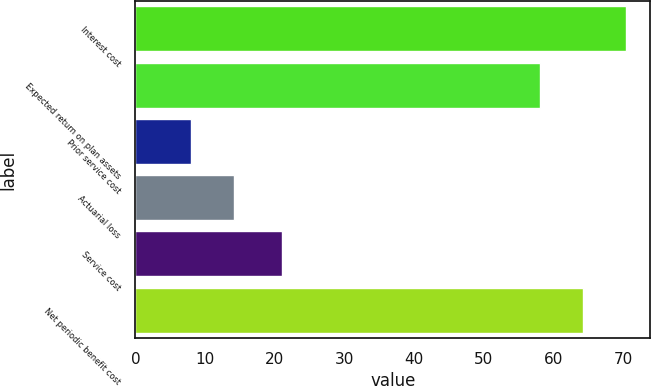<chart> <loc_0><loc_0><loc_500><loc_500><bar_chart><fcel>Interest cost<fcel>Expected return on plan assets<fcel>Prior service cost<fcel>Actuarial loss<fcel>Service cost<fcel>Net periodic benefit cost<nl><fcel>70.4<fcel>58<fcel>8<fcel>14.2<fcel>21<fcel>64.2<nl></chart> 